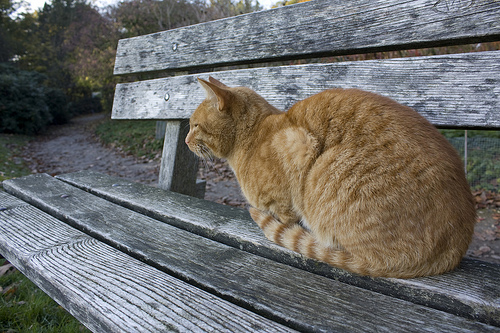What is the name of this animal? The animal is a cat. 